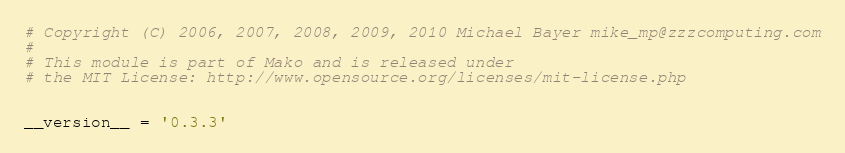Convert code to text. <code><loc_0><loc_0><loc_500><loc_500><_Python_># Copyright (C) 2006, 2007, 2008, 2009, 2010 Michael Bayer mike_mp@zzzcomputing.com
#
# This module is part of Mako and is released under
# the MIT License: http://www.opensource.org/licenses/mit-license.php


__version__ = '0.3.3'

</code> 